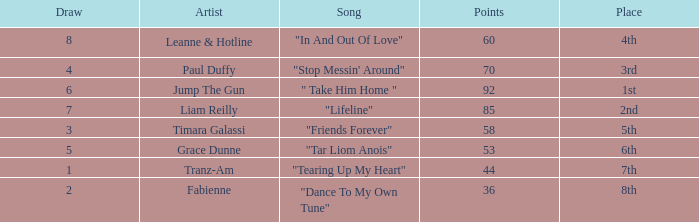What's the total number of points for grace dunne with a draw over 5? 0.0. 